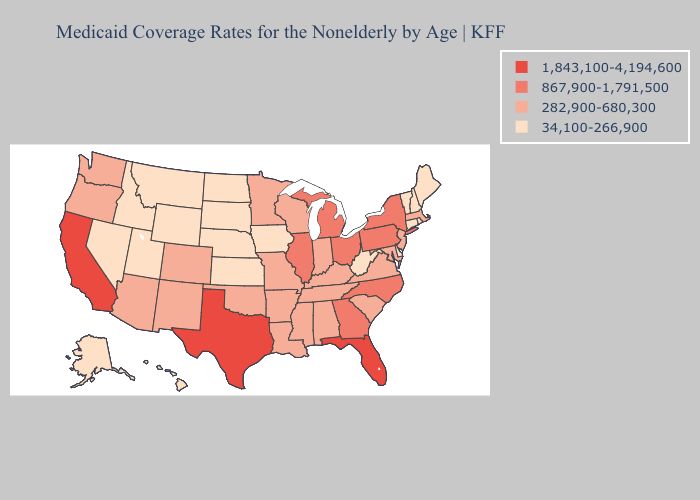Among the states that border Minnesota , which have the highest value?
Quick response, please. Wisconsin. Does Alabama have the lowest value in the South?
Concise answer only. No. Is the legend a continuous bar?
Give a very brief answer. No. Does the map have missing data?
Keep it brief. No. Does Nebraska have the highest value in the USA?
Be succinct. No. Name the states that have a value in the range 282,900-680,300?
Keep it brief. Alabama, Arizona, Arkansas, Colorado, Indiana, Kentucky, Louisiana, Maryland, Massachusetts, Minnesota, Mississippi, Missouri, New Jersey, New Mexico, Oklahoma, Oregon, South Carolina, Tennessee, Virginia, Washington, Wisconsin. Does North Dakota have the highest value in the USA?
Keep it brief. No. Name the states that have a value in the range 1,843,100-4,194,600?
Concise answer only. California, Florida, Texas. How many symbols are there in the legend?
Keep it brief. 4. Which states have the lowest value in the Northeast?
Be succinct. Connecticut, Maine, New Hampshire, Rhode Island, Vermont. Among the states that border New Hampshire , does Maine have the highest value?
Answer briefly. No. Does the first symbol in the legend represent the smallest category?
Write a very short answer. No. Which states have the highest value in the USA?
Quick response, please. California, Florida, Texas. What is the value of Utah?
Short answer required. 34,100-266,900. Name the states that have a value in the range 282,900-680,300?
Concise answer only. Alabama, Arizona, Arkansas, Colorado, Indiana, Kentucky, Louisiana, Maryland, Massachusetts, Minnesota, Mississippi, Missouri, New Jersey, New Mexico, Oklahoma, Oregon, South Carolina, Tennessee, Virginia, Washington, Wisconsin. 